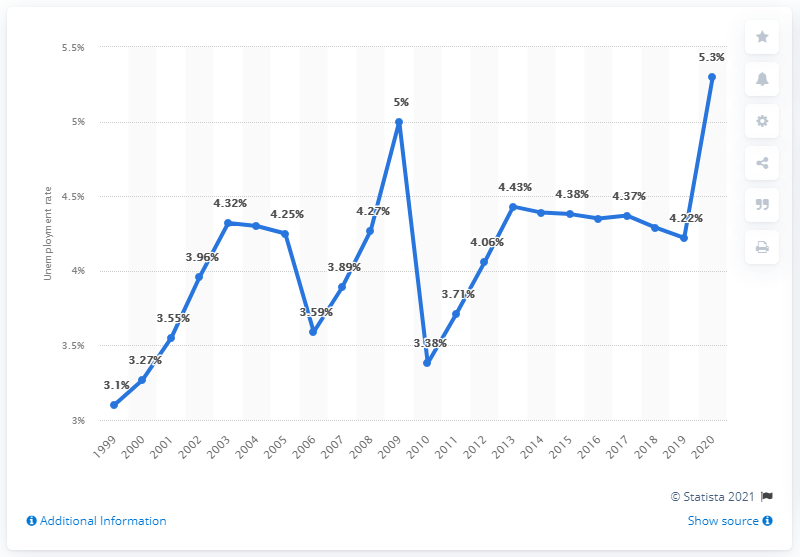Highlight a few significant elements in this photo. In 2011, Bangladesh's unemployment rate was 4.29%. As of 2020, the unemployment rate in Bangladesh was recorded at 5.3%. 